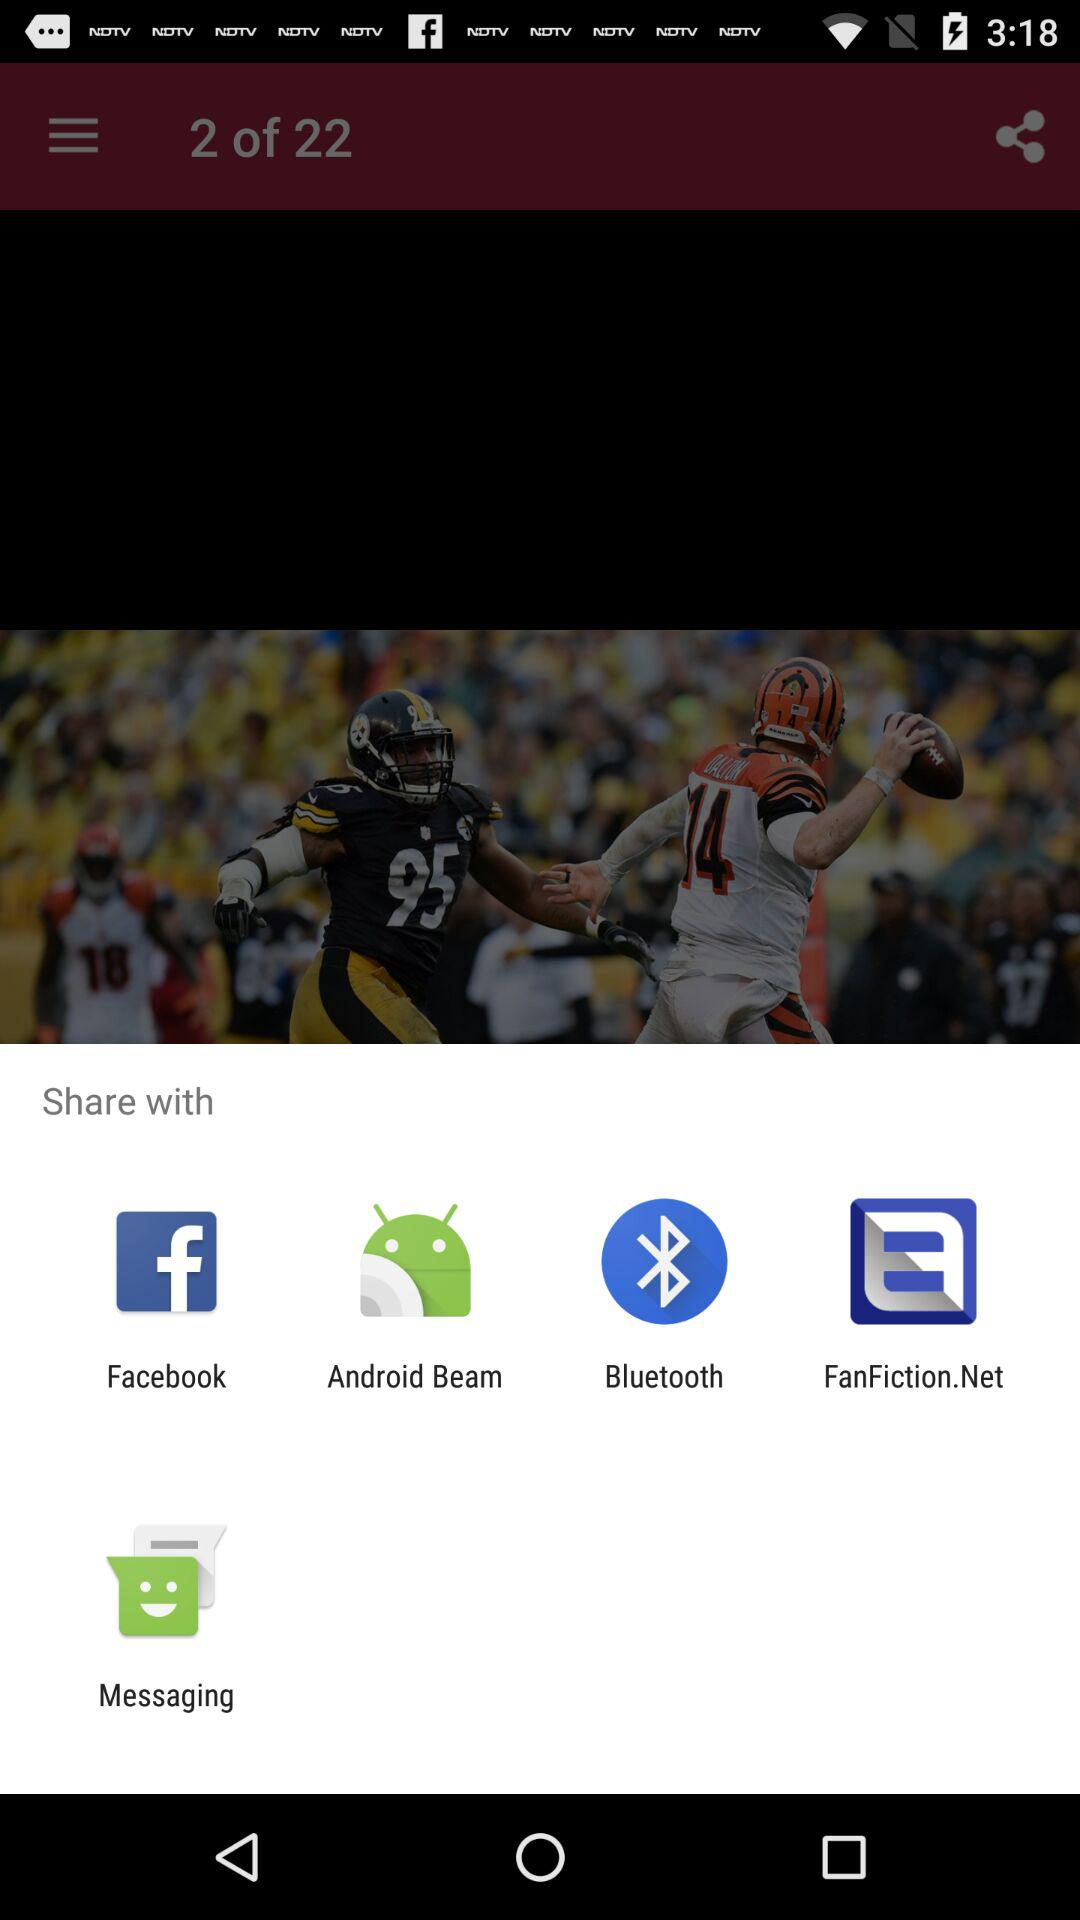Which team seems to be in possession of the ball? Based on the image, the player from the team wearing orange and black, presumably the quarterback, has possession of the ball. Can you describe the actions of the players in the image? Sure! The image captures a moment during an American football game where the quarterback, from the team with orange and black uniforms, is throwing the football. Meanwhile, a player from the opposing team, with a black and yellow uniform, appears to be blocking or attempting to tackle another player. 